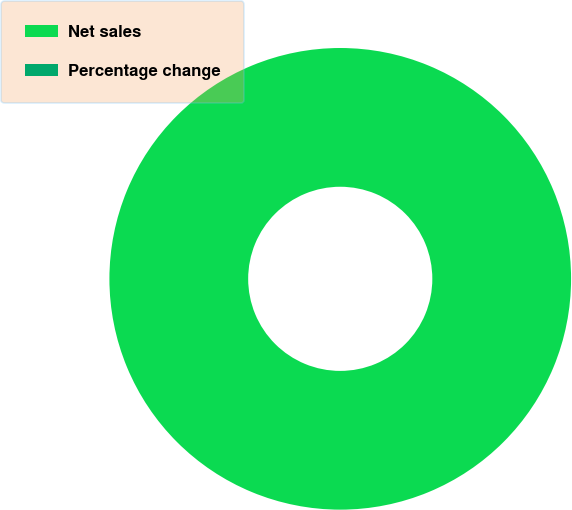<chart> <loc_0><loc_0><loc_500><loc_500><pie_chart><fcel>Net sales<fcel>Percentage change<nl><fcel>100.0%<fcel>0.0%<nl></chart> 